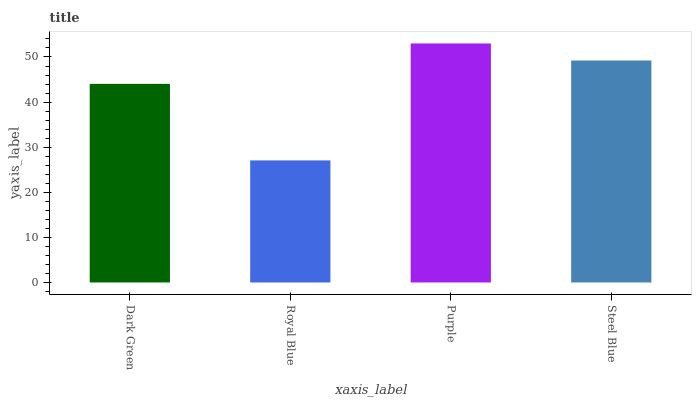Is Royal Blue the minimum?
Answer yes or no. Yes. Is Purple the maximum?
Answer yes or no. Yes. Is Purple the minimum?
Answer yes or no. No. Is Royal Blue the maximum?
Answer yes or no. No. Is Purple greater than Royal Blue?
Answer yes or no. Yes. Is Royal Blue less than Purple?
Answer yes or no. Yes. Is Royal Blue greater than Purple?
Answer yes or no. No. Is Purple less than Royal Blue?
Answer yes or no. No. Is Steel Blue the high median?
Answer yes or no. Yes. Is Dark Green the low median?
Answer yes or no. Yes. Is Royal Blue the high median?
Answer yes or no. No. Is Steel Blue the low median?
Answer yes or no. No. 